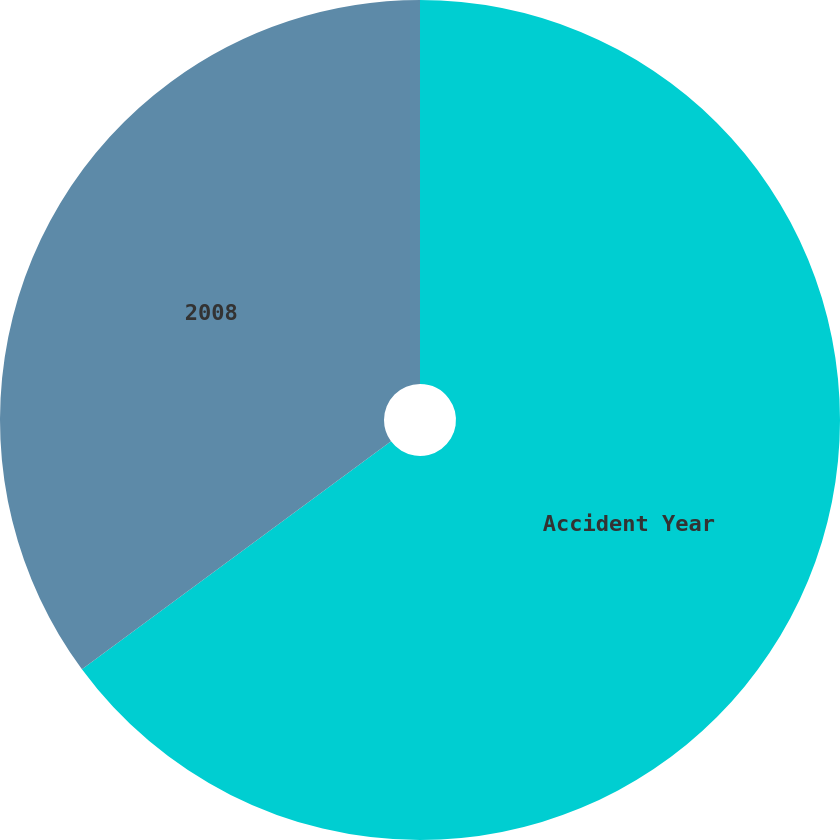Convert chart. <chart><loc_0><loc_0><loc_500><loc_500><pie_chart><fcel>Accident Year<fcel>2008<nl><fcel>64.89%<fcel>35.11%<nl></chart> 